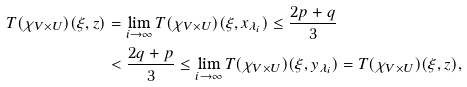<formula> <loc_0><loc_0><loc_500><loc_500>T ( \chi _ { V \times U } ) ( \xi , z ) & = \lim _ { i \to \infty } T ( \chi _ { V \times U } ) ( \xi , x _ { \lambda _ { i } } ) \leq \frac { 2 p + q } { 3 } \\ & < \frac { 2 q + p } { 3 } \leq \lim _ { i \to \infty } T ( \chi _ { V \times U } ) ( \xi , y _ { \lambda _ { i } } ) = T ( \chi _ { V \times U } ) ( \xi , z ) ,</formula> 